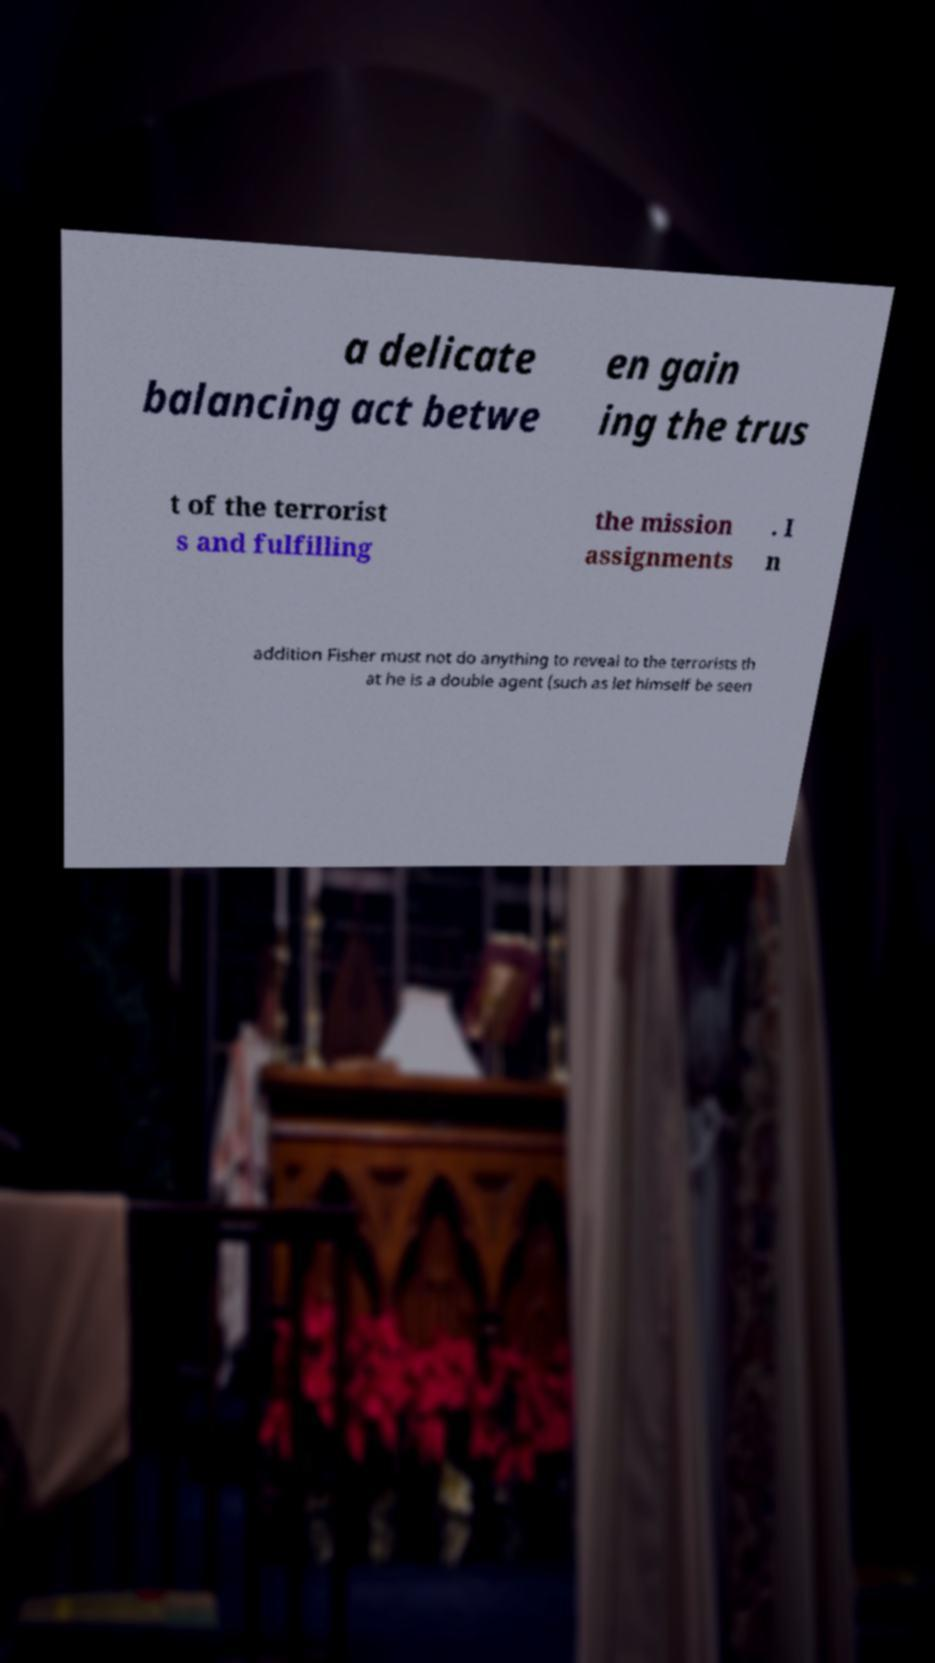Please read and relay the text visible in this image. What does it say? a delicate balancing act betwe en gain ing the trus t of the terrorist s and fulfilling the mission assignments . I n addition Fisher must not do anything to reveal to the terrorists th at he is a double agent (such as let himself be seen 